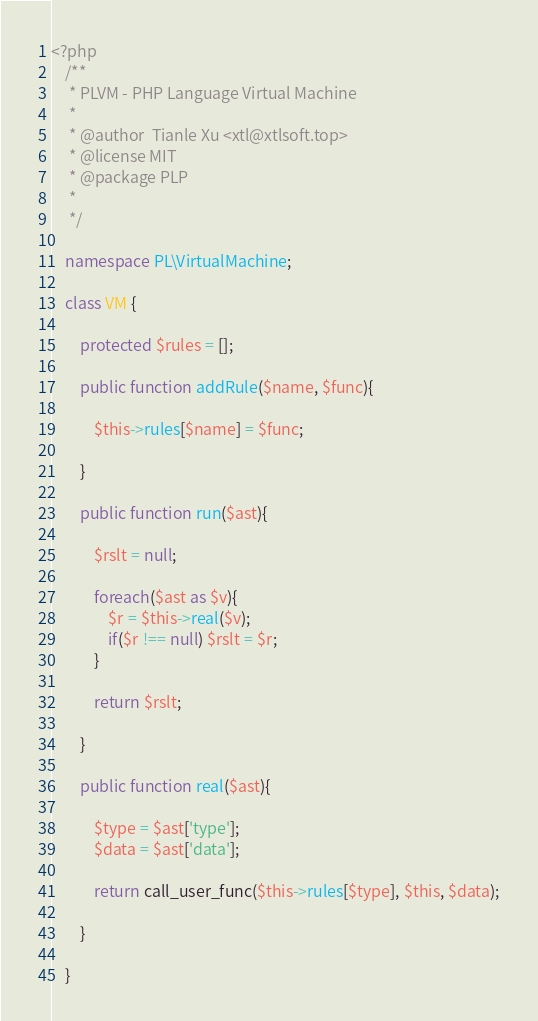Convert code to text. <code><loc_0><loc_0><loc_500><loc_500><_PHP_><?php
    /**
     * PLVM - PHP Language Virtual Machine
     * 
     * @author  Tianle Xu <xtl@xtlsoft.top>
     * @license MIT
     * @package PLP
     * 
     */

    namespace PL\VirtualMachine;

    class VM {

        protected $rules = [];

        public function addRule($name, $func){

            $this->rules[$name] = $func;

        }

        public function run($ast){

            $rslt = null;

            foreach($ast as $v){
                $r = $this->real($v);
                if($r !== null) $rslt = $r;
            }

            return $rslt;

        }

        public function real($ast){

            $type = $ast['type'];
            $data = $ast['data'];

            return call_user_func($this->rules[$type], $this, $data);

        }

    }</code> 